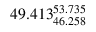Convert formula to latex. <formula><loc_0><loc_0><loc_500><loc_500>4 9 . 4 1 3 _ { 4 6 . 2 5 8 } ^ { 5 3 . 7 3 5 }</formula> 